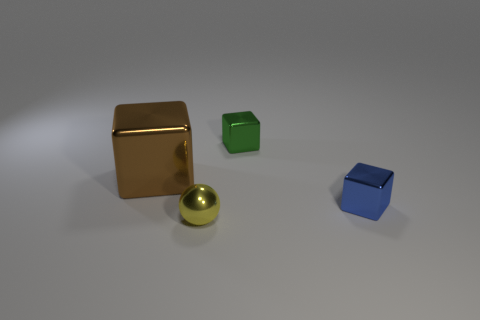Add 2 tiny blue blocks. How many objects exist? 6 Subtract all spheres. How many objects are left? 3 Add 4 big brown shiny cubes. How many big brown shiny cubes are left? 5 Add 4 big brown blocks. How many big brown blocks exist? 5 Subtract 0 brown balls. How many objects are left? 4 Subtract all green rubber cubes. Subtract all tiny yellow balls. How many objects are left? 3 